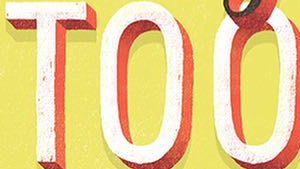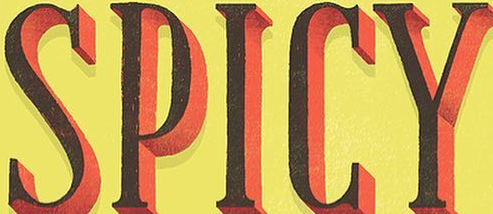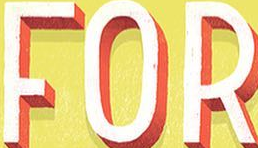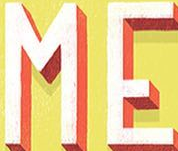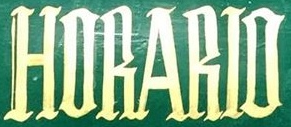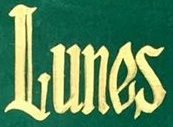Transcribe the words shown in these images in order, separated by a semicolon. TOO; SPICY; FOR; ME; HORARIO; Lunes 